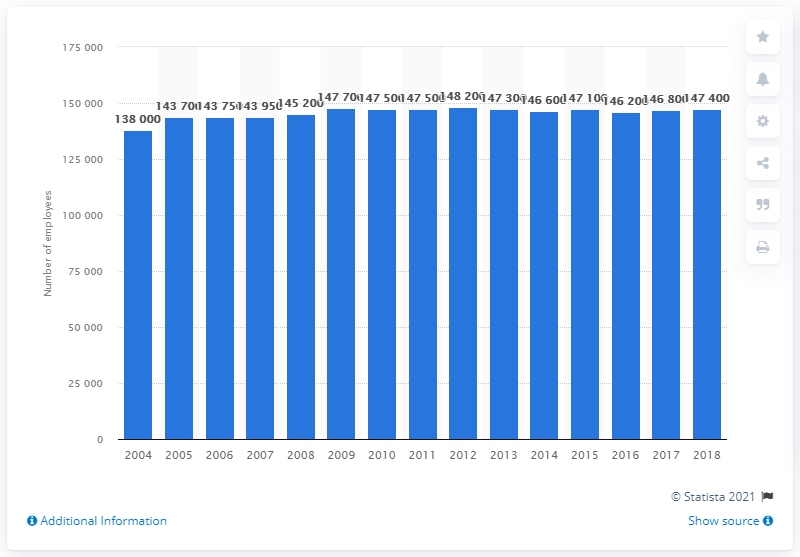List a handful of essential elements in this visual. In 2018, there were approximately 147,400 employees working in the insurance sector in France. 